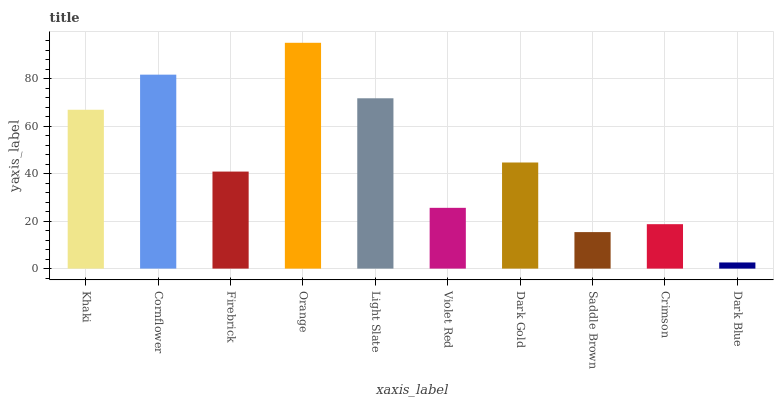Is Dark Blue the minimum?
Answer yes or no. Yes. Is Orange the maximum?
Answer yes or no. Yes. Is Cornflower the minimum?
Answer yes or no. No. Is Cornflower the maximum?
Answer yes or no. No. Is Cornflower greater than Khaki?
Answer yes or no. Yes. Is Khaki less than Cornflower?
Answer yes or no. Yes. Is Khaki greater than Cornflower?
Answer yes or no. No. Is Cornflower less than Khaki?
Answer yes or no. No. Is Dark Gold the high median?
Answer yes or no. Yes. Is Firebrick the low median?
Answer yes or no. Yes. Is Cornflower the high median?
Answer yes or no. No. Is Saddle Brown the low median?
Answer yes or no. No. 